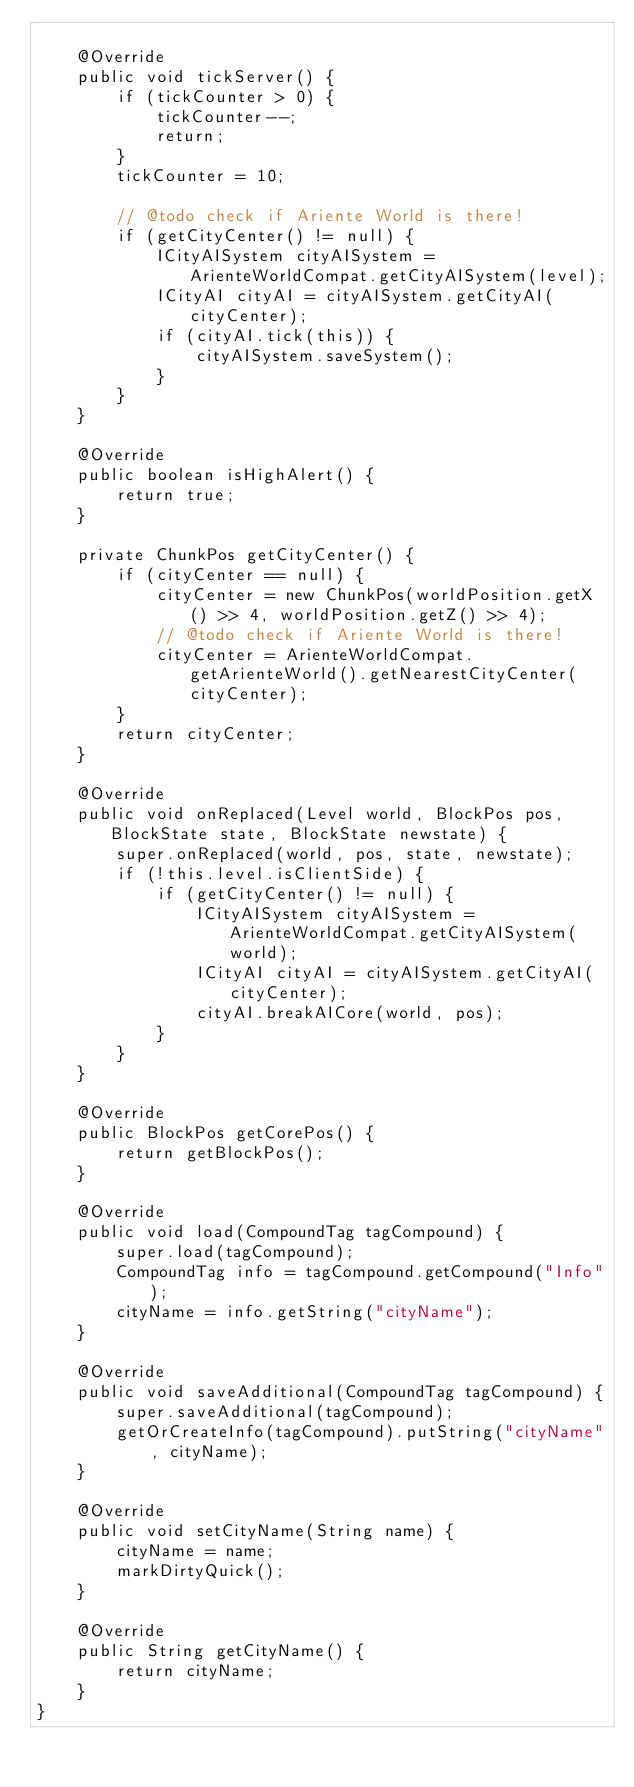Convert code to text. <code><loc_0><loc_0><loc_500><loc_500><_Java_>
    @Override
    public void tickServer() {
        if (tickCounter > 0) {
            tickCounter--;
            return;
        }
        tickCounter = 10;

        // @todo check if Ariente World is there!
        if (getCityCenter() != null) {
            ICityAISystem cityAISystem = ArienteWorldCompat.getCityAISystem(level);
            ICityAI cityAI = cityAISystem.getCityAI(cityCenter);
            if (cityAI.tick(this)) {
                cityAISystem.saveSystem();
            }
        }
    }

    @Override
    public boolean isHighAlert() {
        return true;
    }

    private ChunkPos getCityCenter() {
        if (cityCenter == null) {
            cityCenter = new ChunkPos(worldPosition.getX() >> 4, worldPosition.getZ() >> 4);
            // @todo check if Ariente World is there!
            cityCenter = ArienteWorldCompat.getArienteWorld().getNearestCityCenter(cityCenter);
        }
        return cityCenter;
    }

    @Override
    public void onReplaced(Level world, BlockPos pos, BlockState state, BlockState newstate) {
        super.onReplaced(world, pos, state, newstate);
        if (!this.level.isClientSide) {
            if (getCityCenter() != null) {
                ICityAISystem cityAISystem = ArienteWorldCompat.getCityAISystem(world);
                ICityAI cityAI = cityAISystem.getCityAI(cityCenter);
                cityAI.breakAICore(world, pos);
            }
        }
    }

    @Override
    public BlockPos getCorePos() {
        return getBlockPos();
    }

    @Override
    public void load(CompoundTag tagCompound) {
        super.load(tagCompound);
        CompoundTag info = tagCompound.getCompound("Info");
        cityName = info.getString("cityName");
    }

    @Override
    public void saveAdditional(CompoundTag tagCompound) {
        super.saveAdditional(tagCompound);
        getOrCreateInfo(tagCompound).putString("cityName", cityName);
    }

    @Override
    public void setCityName(String name) {
        cityName = name;
        markDirtyQuick();
    }

    @Override
    public String getCityName() {
        return cityName;
    }
}
</code> 